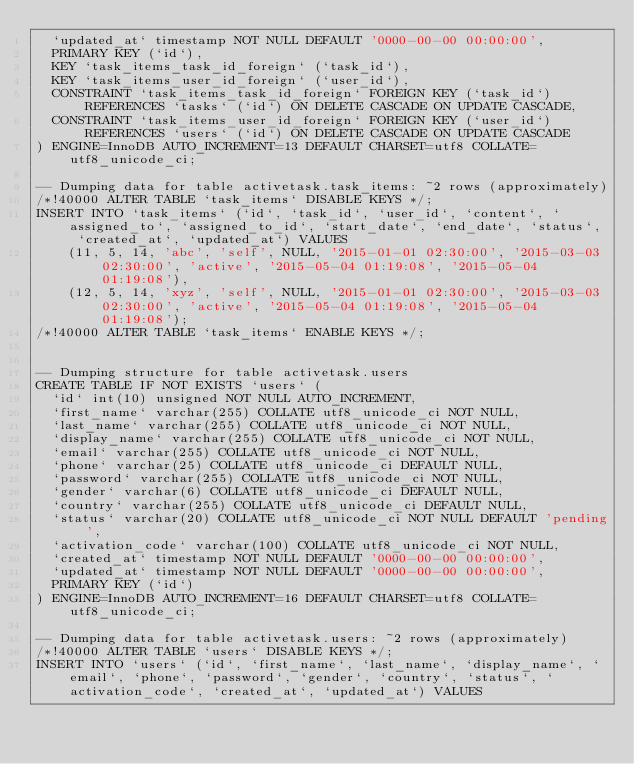Convert code to text. <code><loc_0><loc_0><loc_500><loc_500><_SQL_>  `updated_at` timestamp NOT NULL DEFAULT '0000-00-00 00:00:00',
  PRIMARY KEY (`id`),
  KEY `task_items_task_id_foreign` (`task_id`),
  KEY `task_items_user_id_foreign` (`user_id`),
  CONSTRAINT `task_items_task_id_foreign` FOREIGN KEY (`task_id`) REFERENCES `tasks` (`id`) ON DELETE CASCADE ON UPDATE CASCADE,
  CONSTRAINT `task_items_user_id_foreign` FOREIGN KEY (`user_id`) REFERENCES `users` (`id`) ON DELETE CASCADE ON UPDATE CASCADE
) ENGINE=InnoDB AUTO_INCREMENT=13 DEFAULT CHARSET=utf8 COLLATE=utf8_unicode_ci;

-- Dumping data for table activetask.task_items: ~2 rows (approximately)
/*!40000 ALTER TABLE `task_items` DISABLE KEYS */;
INSERT INTO `task_items` (`id`, `task_id`, `user_id`, `content`, `assigned_to`, `assigned_to_id`, `start_date`, `end_date`, `status`, `created_at`, `updated_at`) VALUES
	(11, 5, 14, 'abc', 'self', NULL, '2015-01-01 02:30:00', '2015-03-03 02:30:00', 'active', '2015-05-04 01:19:08', '2015-05-04 01:19:08'),
	(12, 5, 14, 'xyz', 'self', NULL, '2015-01-01 02:30:00', '2015-03-03 02:30:00', 'active', '2015-05-04 01:19:08', '2015-05-04 01:19:08');
/*!40000 ALTER TABLE `task_items` ENABLE KEYS */;


-- Dumping structure for table activetask.users
CREATE TABLE IF NOT EXISTS `users` (
  `id` int(10) unsigned NOT NULL AUTO_INCREMENT,
  `first_name` varchar(255) COLLATE utf8_unicode_ci NOT NULL,
  `last_name` varchar(255) COLLATE utf8_unicode_ci NOT NULL,
  `display_name` varchar(255) COLLATE utf8_unicode_ci NOT NULL,
  `email` varchar(255) COLLATE utf8_unicode_ci NOT NULL,
  `phone` varchar(25) COLLATE utf8_unicode_ci DEFAULT NULL,
  `password` varchar(255) COLLATE utf8_unicode_ci NOT NULL,
  `gender` varchar(6) COLLATE utf8_unicode_ci DEFAULT NULL,
  `country` varchar(255) COLLATE utf8_unicode_ci DEFAULT NULL,
  `status` varchar(20) COLLATE utf8_unicode_ci NOT NULL DEFAULT 'pending',
  `activation_code` varchar(100) COLLATE utf8_unicode_ci NOT NULL,
  `created_at` timestamp NOT NULL DEFAULT '0000-00-00 00:00:00',
  `updated_at` timestamp NOT NULL DEFAULT '0000-00-00 00:00:00',
  PRIMARY KEY (`id`)
) ENGINE=InnoDB AUTO_INCREMENT=16 DEFAULT CHARSET=utf8 COLLATE=utf8_unicode_ci;

-- Dumping data for table activetask.users: ~2 rows (approximately)
/*!40000 ALTER TABLE `users` DISABLE KEYS */;
INSERT INTO `users` (`id`, `first_name`, `last_name`, `display_name`, `email`, `phone`, `password`, `gender`, `country`, `status`, `activation_code`, `created_at`, `updated_at`) VALUES</code> 